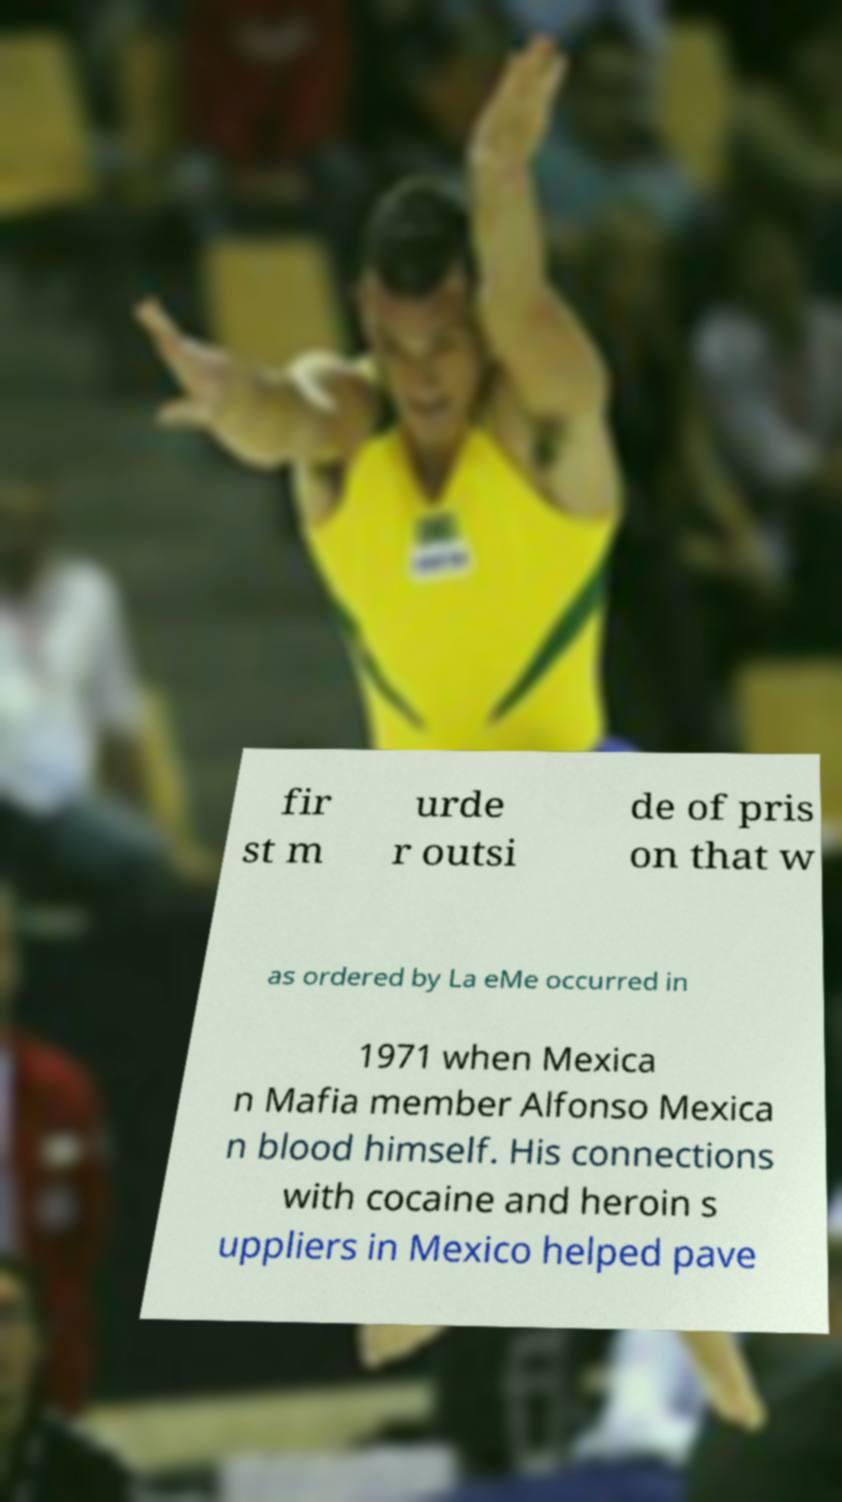What messages or text are displayed in this image? I need them in a readable, typed format. fir st m urde r outsi de of pris on that w as ordered by La eMe occurred in 1971 when Mexica n Mafia member Alfonso Mexica n blood himself. His connections with cocaine and heroin s uppliers in Mexico helped pave 